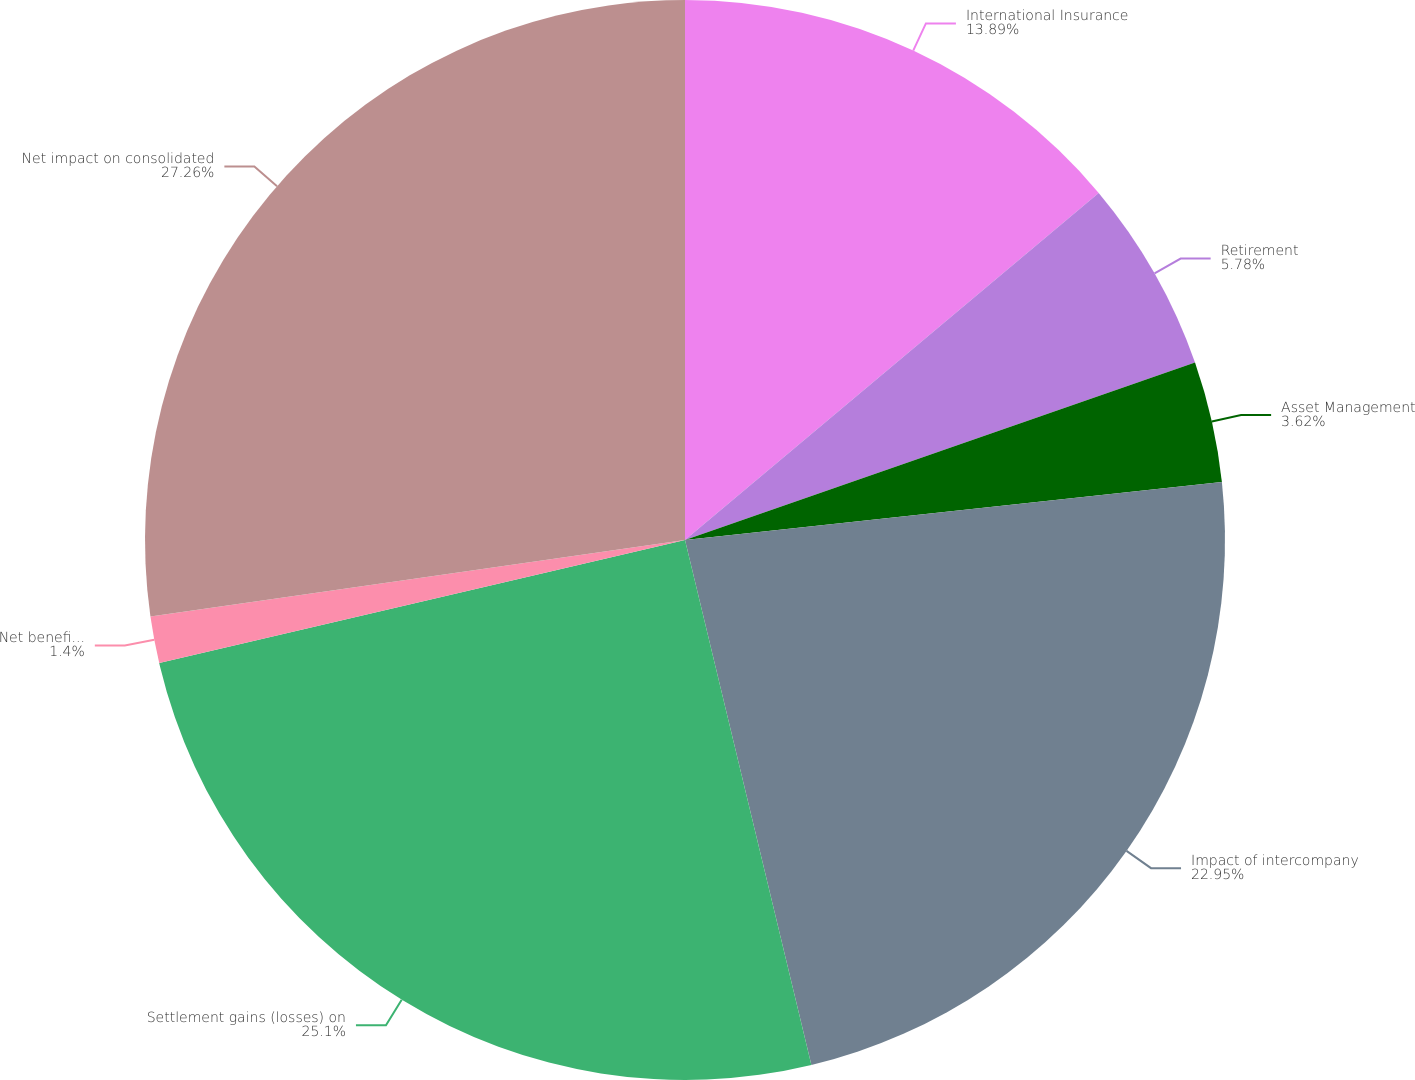Convert chart to OTSL. <chart><loc_0><loc_0><loc_500><loc_500><pie_chart><fcel>International Insurance<fcel>Retirement<fcel>Asset Management<fcel>Impact of intercompany<fcel>Settlement gains (losses) on<fcel>Net benefit (detriment) to<fcel>Net impact on consolidated<nl><fcel>13.89%<fcel>5.78%<fcel>3.62%<fcel>22.95%<fcel>25.1%<fcel>1.4%<fcel>27.26%<nl></chart> 